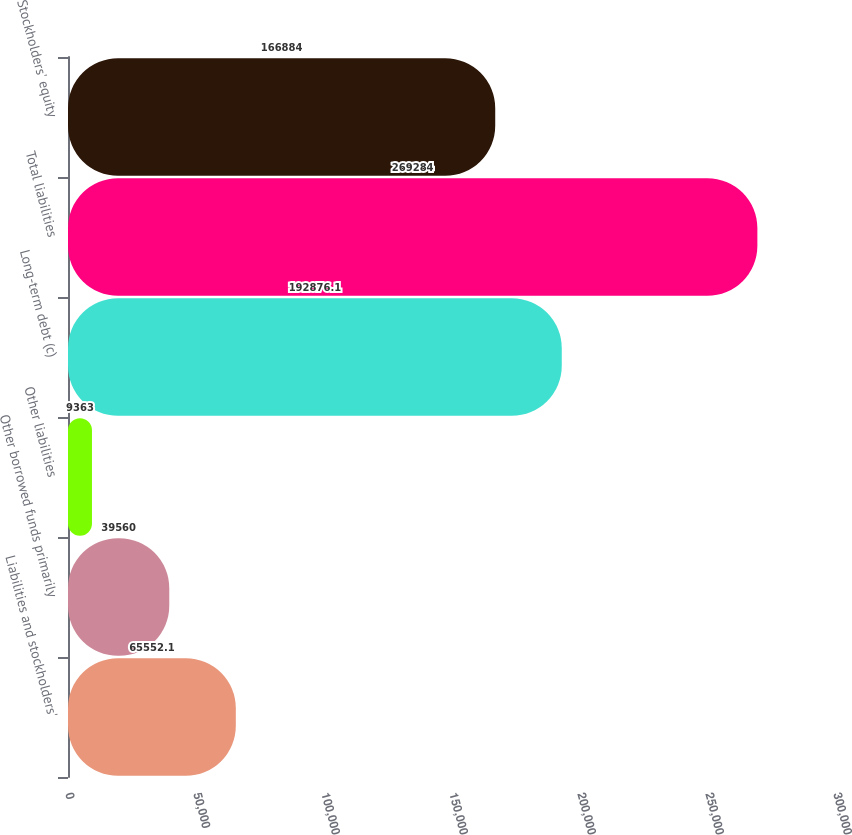Convert chart to OTSL. <chart><loc_0><loc_0><loc_500><loc_500><bar_chart><fcel>Liabilities and stockholders'<fcel>Other borrowed funds primarily<fcel>Other liabilities<fcel>Long-term debt (c)<fcel>Total liabilities<fcel>Stockholders' equity<nl><fcel>65552.1<fcel>39560<fcel>9363<fcel>192876<fcel>269284<fcel>166884<nl></chart> 